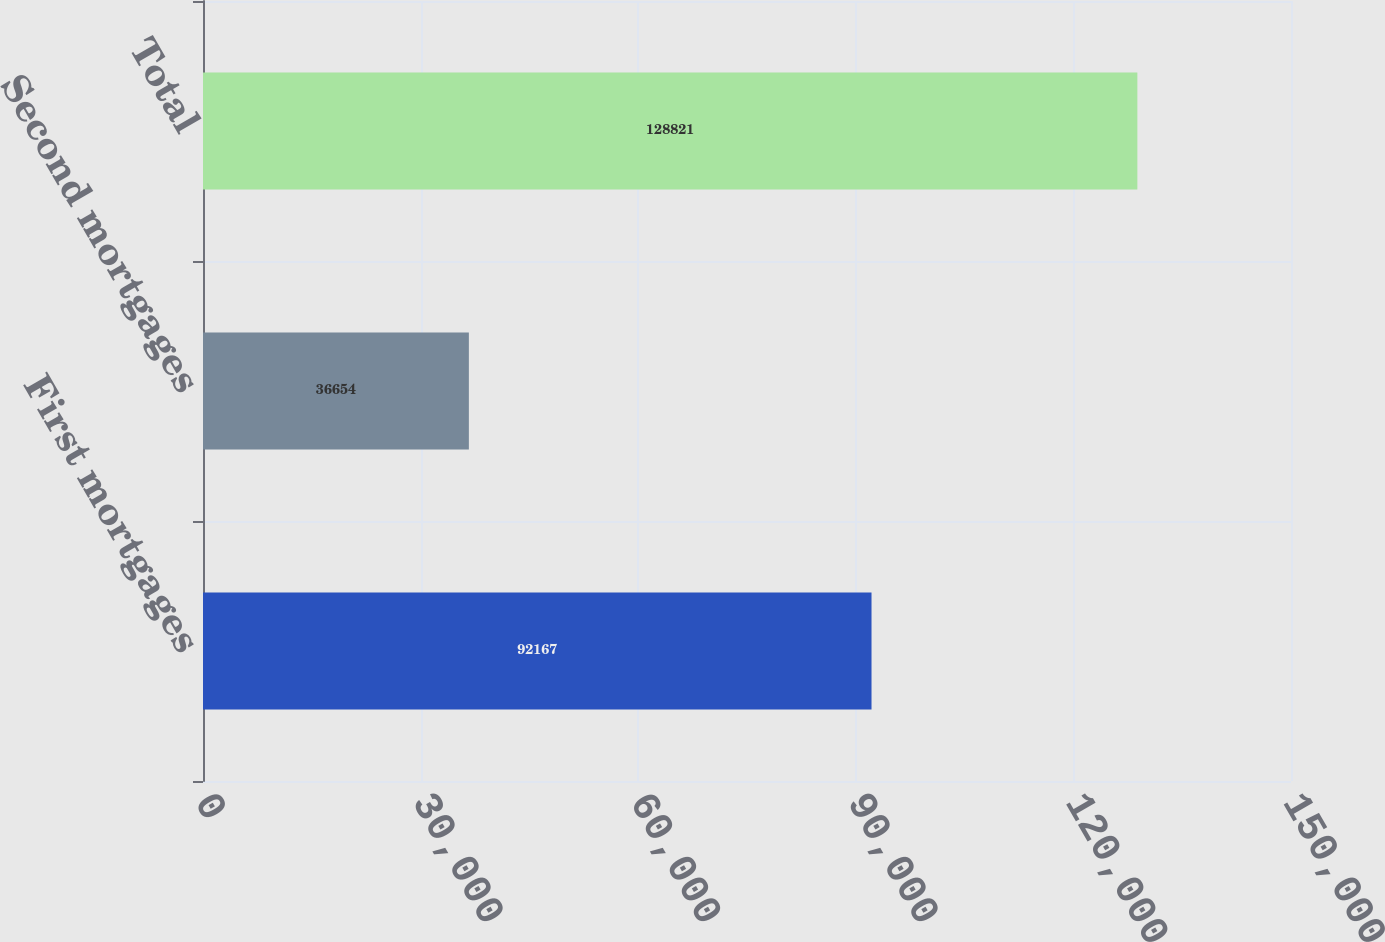<chart> <loc_0><loc_0><loc_500><loc_500><bar_chart><fcel>First mortgages<fcel>Second mortgages<fcel>Total<nl><fcel>92167<fcel>36654<fcel>128821<nl></chart> 